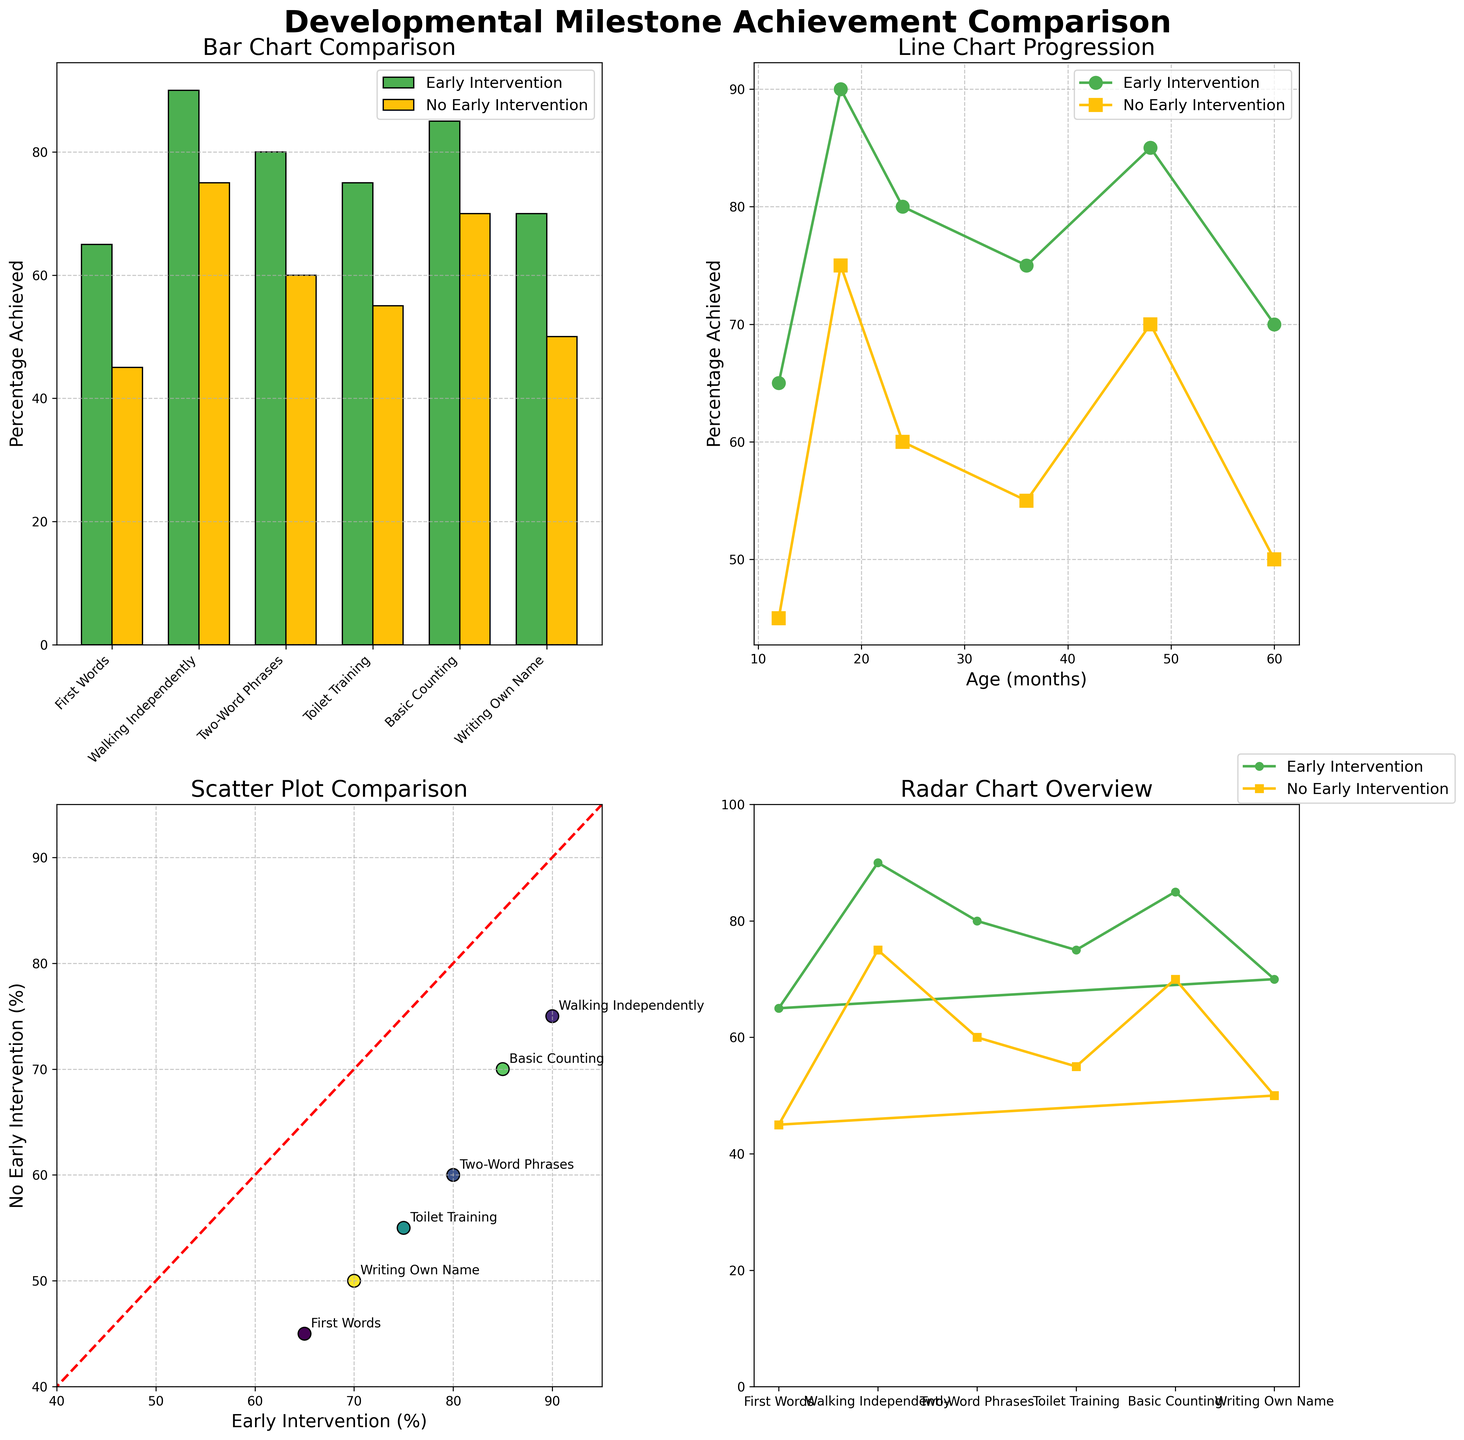what's the title of the entire figure? The title is displayed prominently at the top of the figure, showing the subject of the plots. The title is "Developmental Milestone Achievement Comparison."
Answer: Developmental Milestone Achievement Comparison Which group generally shows a higher percentage of milestone achievement: children with early intervention or without? By comparing the two groups across all subplots, it shows that children with early intervention consistently achieve higher milestone percentages compared to those without. This is evident from the bar, line, scatter, and radar charts where the green 'Early Intervention' indicators are consistently above or equal to the yellow 'No Early Intervention' ones.
Answer: Early Intervention What's the percentage difference in First Words achievement between children with and without early intervention? From the bar chart, we see that First Words achievement is 65% for early intervention and 45% for no early intervention, resulting in a 20% difference (65% - 45%).
Answer: 20% Looking at the line chart, which milestone shows the greatest difference in achievement percentages between the two groups? By examining the distances between the two lines on the line chart, Toilet Training (at 36 months) shows the greatest difference, with early intervention at 75% and no early intervention at 55%. This results in a 20% difference.
Answer: Toilet Training What milestone has the closest achievement percentages between the two groups? Both the line and radar charts show that Walking Independently (at 18 months) has the smallest difference, with 90% for early intervention and 75% for no early intervention, resulting in a 15% difference.
Answer: Walking Independently In the scatter plot, which milestone is closest to the diagonal line, indicating equal achievement percentages in both groups? The scatter plot reveals that Writing Own Name (at 60 months) is closest to the diagonal line, but with differences still present, showing 70% for early intervention and 50% for no early intervention.
Answer: Writing Own Name What percentage of children with early intervention achieved Toilet Training by 36 months? From any of the subplots where percentage data is shown, we see that 75% of children with early intervention achieved Toilet Training by 36 months.
Answer: 75% How much higher is the percentage of children achieving Basic Counting with early intervention compared to no early intervention? From the charts, Basic Counting (at 48 months) is achieved by 85% of children with early intervention and 70% without. The difference is 15% (85% - 70%).
Answer: 15% Which milestone has the greatest gap in achievement by 60 months according to the radar chart? The radar chart shows that Writing Own Name has the greatest gap at 60 months, with early intervention at 70% and no early intervention at 50%, resulting in a 20% gap.
Answer: Writing Own Name 